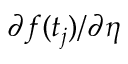Convert formula to latex. <formula><loc_0><loc_0><loc_500><loc_500>\partial f ( t _ { j } ) / \partial \eta</formula> 